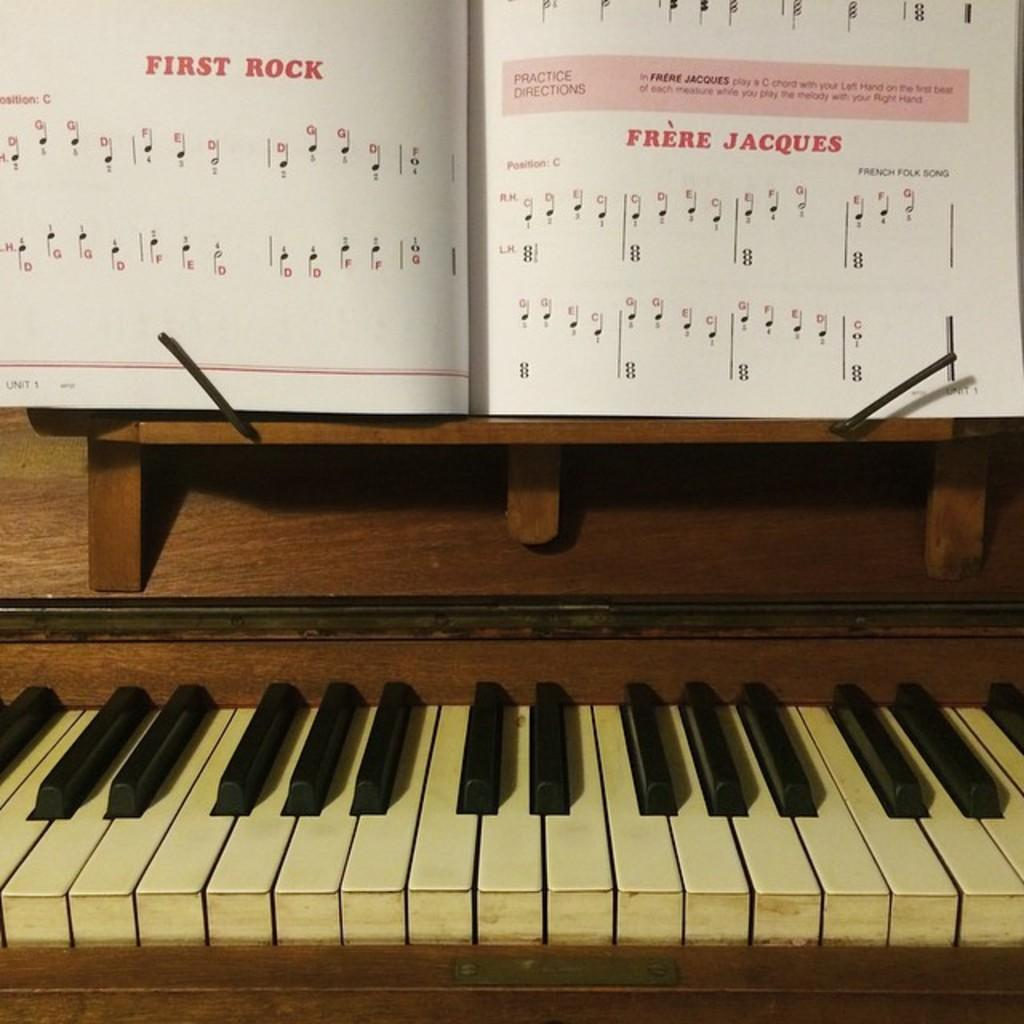What musical instrument is present in the image? There is a piano in the image. What object related to reading can be seen in the image? There is a book in the image. Can you hear the worm making a cry sound in the image? There is no worm present in the image, and therefore no such sound can be heard. 